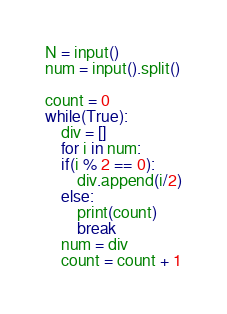Convert code to text. <code><loc_0><loc_0><loc_500><loc_500><_Python_>N = input()
num = input().split()

count = 0
while(True):
	div = []
	for i in num:
	if(i % 2 == 0):
    	div.append(i/2)
    else:
	  	print(count)
        break
	num = div
	count = count + 1

</code> 